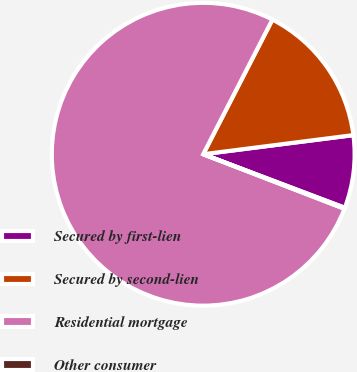<chart> <loc_0><loc_0><loc_500><loc_500><pie_chart><fcel>Secured by first-lien<fcel>Secured by second-lien<fcel>Residential mortgage<fcel>Other consumer<nl><fcel>7.77%<fcel>15.43%<fcel>76.7%<fcel>0.11%<nl></chart> 